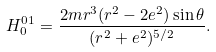Convert formula to latex. <formula><loc_0><loc_0><loc_500><loc_500>H _ { 0 } ^ { 0 1 } = \frac { 2 m r ^ { 3 } ( r ^ { 2 } - 2 e ^ { 2 } ) \sin \theta } { ( r ^ { 2 } + e ^ { 2 } ) ^ { 5 / 2 } } .</formula> 